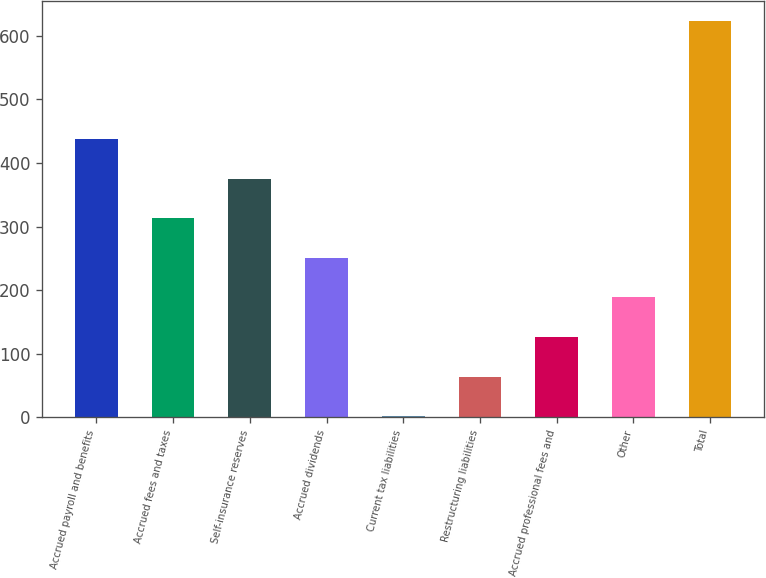<chart> <loc_0><loc_0><loc_500><loc_500><bar_chart><fcel>Accrued payroll and benefits<fcel>Accrued fees and taxes<fcel>Self-insurance reserves<fcel>Accrued dividends<fcel>Current tax liabilities<fcel>Restructuring liabilities<fcel>Accrued professional fees and<fcel>Other<fcel>Total<nl><fcel>437.15<fcel>312.85<fcel>375<fcel>250.7<fcel>2.1<fcel>64.25<fcel>126.4<fcel>188.55<fcel>623.6<nl></chart> 